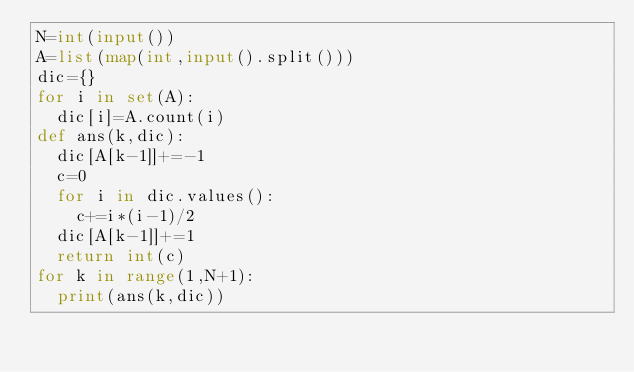<code> <loc_0><loc_0><loc_500><loc_500><_Python_>N=int(input())
A=list(map(int,input().split()))
dic={}
for i in set(A):
  dic[i]=A.count(i) 
def ans(k,dic):
  dic[A[k-1]]+=-1
  c=0
  for i in dic.values():
    c+=i*(i-1)/2
  dic[A[k-1]]+=1  
  return int(c)
for k in range(1,N+1):
  print(ans(k,dic))
      </code> 